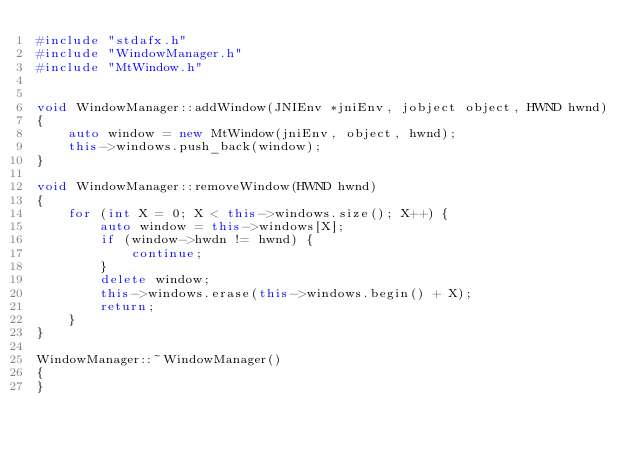Convert code to text. <code><loc_0><loc_0><loc_500><loc_500><_C++_>#include "stdafx.h"
#include "WindowManager.h"
#include "MtWindow.h"


void WindowManager::addWindow(JNIEnv *jniEnv, jobject object, HWND hwnd)
{
	auto window = new MtWindow(jniEnv, object, hwnd);
	this->windows.push_back(window);
}

void WindowManager::removeWindow(HWND hwnd)
{
	for (int X = 0; X < this->windows.size(); X++) {
		auto window = this->windows[X];
		if (window->hwdn != hwnd) {
			continue;
		}
		delete window;
		this->windows.erase(this->windows.begin() + X);
		return;
	}
}

WindowManager::~WindowManager()
{
}
</code> 